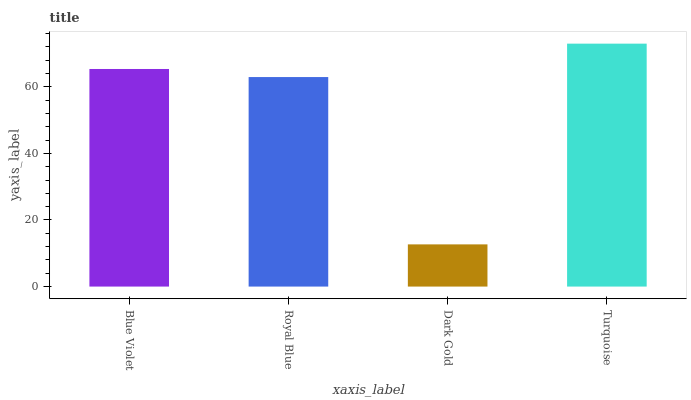Is Turquoise the maximum?
Answer yes or no. Yes. Is Royal Blue the minimum?
Answer yes or no. No. Is Royal Blue the maximum?
Answer yes or no. No. Is Blue Violet greater than Royal Blue?
Answer yes or no. Yes. Is Royal Blue less than Blue Violet?
Answer yes or no. Yes. Is Royal Blue greater than Blue Violet?
Answer yes or no. No. Is Blue Violet less than Royal Blue?
Answer yes or no. No. Is Blue Violet the high median?
Answer yes or no. Yes. Is Royal Blue the low median?
Answer yes or no. Yes. Is Royal Blue the high median?
Answer yes or no. No. Is Blue Violet the low median?
Answer yes or no. No. 